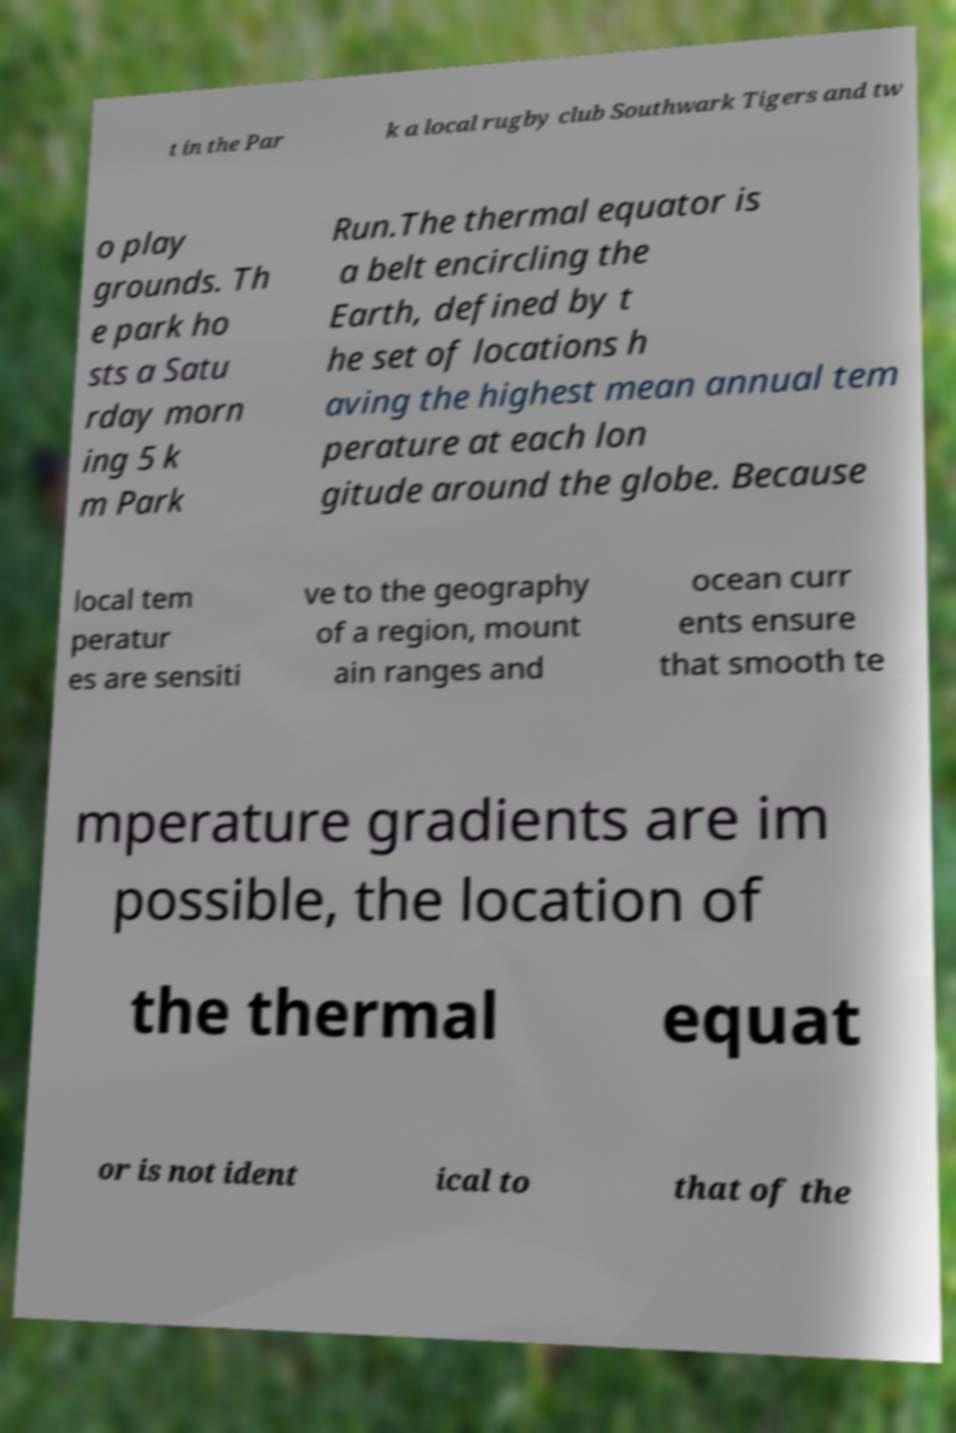Please read and relay the text visible in this image. What does it say? t in the Par k a local rugby club Southwark Tigers and tw o play grounds. Th e park ho sts a Satu rday morn ing 5 k m Park Run.The thermal equator is a belt encircling the Earth, defined by t he set of locations h aving the highest mean annual tem perature at each lon gitude around the globe. Because local tem peratur es are sensiti ve to the geography of a region, mount ain ranges and ocean curr ents ensure that smooth te mperature gradients are im possible, the location of the thermal equat or is not ident ical to that of the 